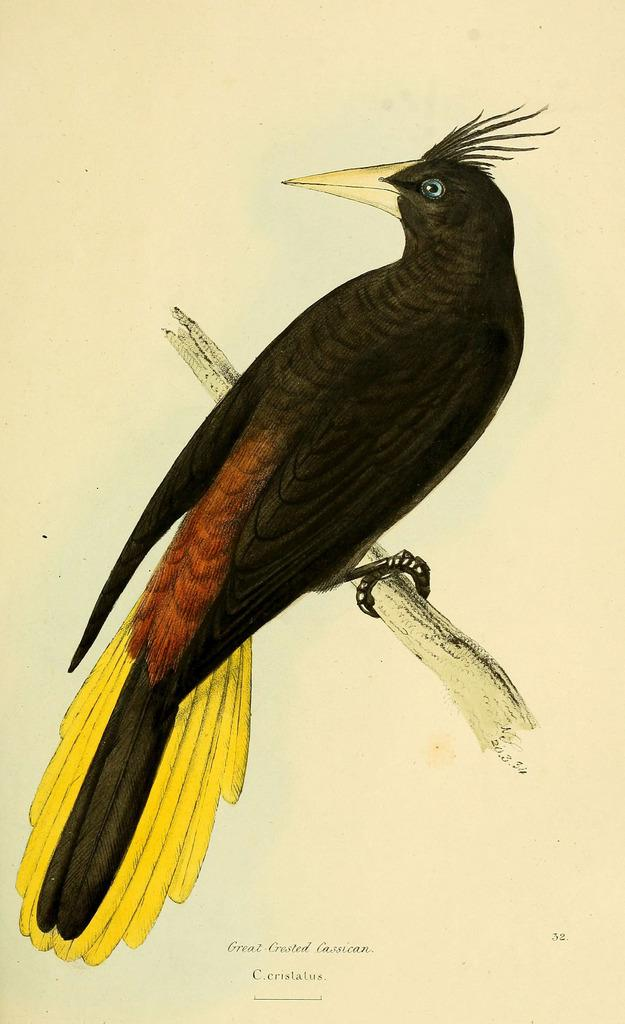What is the main subject of the image? The image contains a painting. What can be seen in the painting? There is a bird on a wooden trunk in the painting. Is there any text present in the image? Yes, there is some text at the bottom of the image. How many mice are hiding in the locket in the image? There is no locket or mice present in the image. 